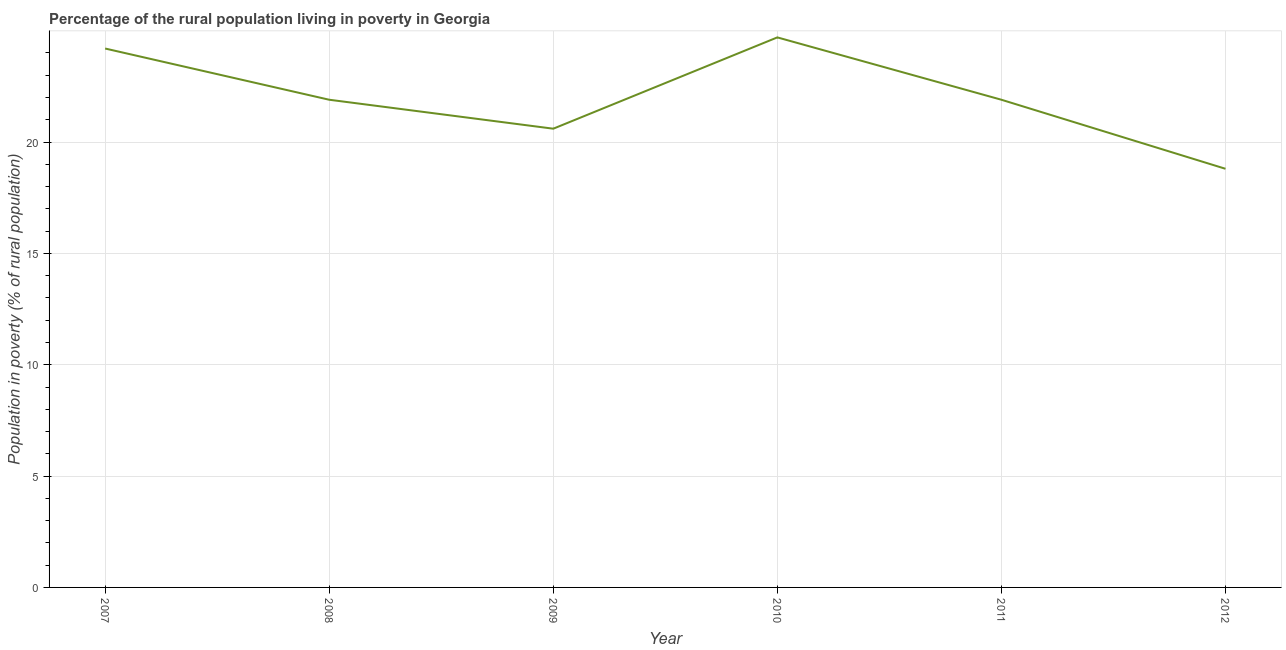What is the percentage of rural population living below poverty line in 2010?
Offer a very short reply. 24.7. Across all years, what is the maximum percentage of rural population living below poverty line?
Offer a terse response. 24.7. In which year was the percentage of rural population living below poverty line maximum?
Offer a terse response. 2010. What is the sum of the percentage of rural population living below poverty line?
Provide a succinct answer. 132.1. What is the average percentage of rural population living below poverty line per year?
Provide a succinct answer. 22.02. What is the median percentage of rural population living below poverty line?
Offer a terse response. 21.9. In how many years, is the percentage of rural population living below poverty line greater than 15 %?
Keep it short and to the point. 6. What is the ratio of the percentage of rural population living below poverty line in 2009 to that in 2011?
Ensure brevity in your answer.  0.94. Is the difference between the percentage of rural population living below poverty line in 2010 and 2011 greater than the difference between any two years?
Your answer should be compact. No. What is the difference between the highest and the second highest percentage of rural population living below poverty line?
Provide a succinct answer. 0.5. What is the difference between the highest and the lowest percentage of rural population living below poverty line?
Offer a terse response. 5.9. What is the difference between two consecutive major ticks on the Y-axis?
Ensure brevity in your answer.  5. Are the values on the major ticks of Y-axis written in scientific E-notation?
Your answer should be compact. No. Does the graph contain any zero values?
Your answer should be compact. No. Does the graph contain grids?
Provide a short and direct response. Yes. What is the title of the graph?
Your response must be concise. Percentage of the rural population living in poverty in Georgia. What is the label or title of the Y-axis?
Offer a very short reply. Population in poverty (% of rural population). What is the Population in poverty (% of rural population) of 2007?
Ensure brevity in your answer.  24.2. What is the Population in poverty (% of rural population) of 2008?
Your answer should be very brief. 21.9. What is the Population in poverty (% of rural population) of 2009?
Offer a terse response. 20.6. What is the Population in poverty (% of rural population) of 2010?
Make the answer very short. 24.7. What is the Population in poverty (% of rural population) of 2011?
Your response must be concise. 21.9. What is the Population in poverty (% of rural population) in 2012?
Make the answer very short. 18.8. What is the difference between the Population in poverty (% of rural population) in 2007 and 2008?
Ensure brevity in your answer.  2.3. What is the difference between the Population in poverty (% of rural population) in 2007 and 2012?
Your answer should be compact. 5.4. What is the difference between the Population in poverty (% of rural population) in 2008 and 2011?
Offer a terse response. 0. What is the difference between the Population in poverty (% of rural population) in 2008 and 2012?
Offer a very short reply. 3.1. What is the difference between the Population in poverty (% of rural population) in 2009 and 2012?
Your response must be concise. 1.8. What is the difference between the Population in poverty (% of rural population) in 2010 and 2011?
Give a very brief answer. 2.8. What is the ratio of the Population in poverty (% of rural population) in 2007 to that in 2008?
Your answer should be very brief. 1.1. What is the ratio of the Population in poverty (% of rural population) in 2007 to that in 2009?
Offer a very short reply. 1.18. What is the ratio of the Population in poverty (% of rural population) in 2007 to that in 2011?
Make the answer very short. 1.1. What is the ratio of the Population in poverty (% of rural population) in 2007 to that in 2012?
Offer a very short reply. 1.29. What is the ratio of the Population in poverty (% of rural population) in 2008 to that in 2009?
Give a very brief answer. 1.06. What is the ratio of the Population in poverty (% of rural population) in 2008 to that in 2010?
Give a very brief answer. 0.89. What is the ratio of the Population in poverty (% of rural population) in 2008 to that in 2012?
Provide a succinct answer. 1.17. What is the ratio of the Population in poverty (% of rural population) in 2009 to that in 2010?
Provide a short and direct response. 0.83. What is the ratio of the Population in poverty (% of rural population) in 2009 to that in 2011?
Provide a succinct answer. 0.94. What is the ratio of the Population in poverty (% of rural population) in 2009 to that in 2012?
Offer a very short reply. 1.1. What is the ratio of the Population in poverty (% of rural population) in 2010 to that in 2011?
Ensure brevity in your answer.  1.13. What is the ratio of the Population in poverty (% of rural population) in 2010 to that in 2012?
Give a very brief answer. 1.31. What is the ratio of the Population in poverty (% of rural population) in 2011 to that in 2012?
Offer a very short reply. 1.17. 